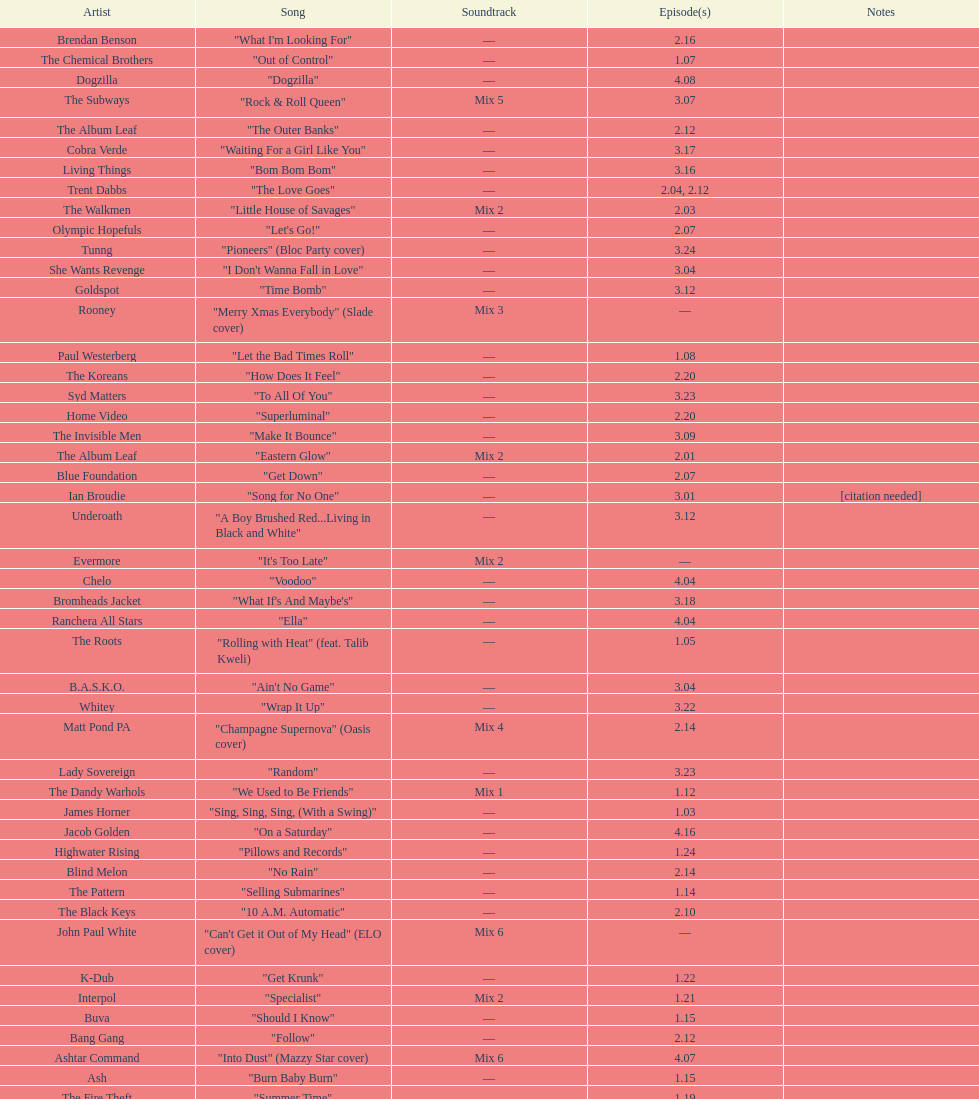How many consecutive songs were by the album leaf? 6. 